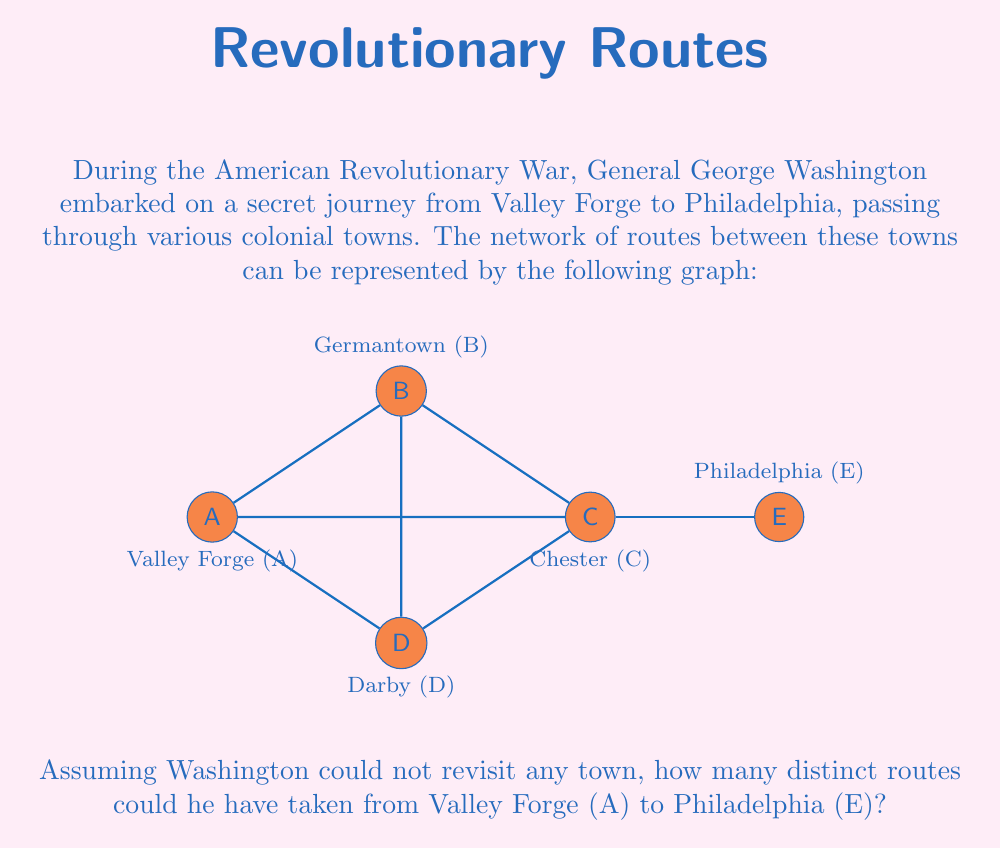Show me your answer to this math problem. To solve this problem, we'll use the principles of graph theory and combinatorics. Let's approach this step-by-step:

1) First, observe that all paths from A to E must pass through C. This simplifies our problem into two parts:
   - Counting paths from A to C
   - Adding the single step from C to E

2) To count paths from A to C, we can use the concept of topological sorting. We need to count the number of ways to arrange the vertices A, B, C, and D, respecting the edge constraints.

3) Let's count the possible arrangements:
   - A must come first (it's the starting point)
   - C must come before D (due to the edge direction)
   - B can be placed in any position after A

4) This gives us the following possible orderings:
   - ABCD
   - ACBD
   - ACDB

5) Each of these orderings represents a unique path:
   - ABCD: A → B → C → D → C
   - ACBD: A → C → B → D → C
   - ACDB: A → C → D → B → C

6) After reaching C in each of these paths, there's only one way to reach E.

Therefore, the total number of distinct routes from A to E is equal to the number of paths from A to C, which is 3.

This problem demonstrates how graph theory can be applied to historical scenarios, blending the persona's interest in history with mathematical concepts.
Answer: 3 distinct routes 